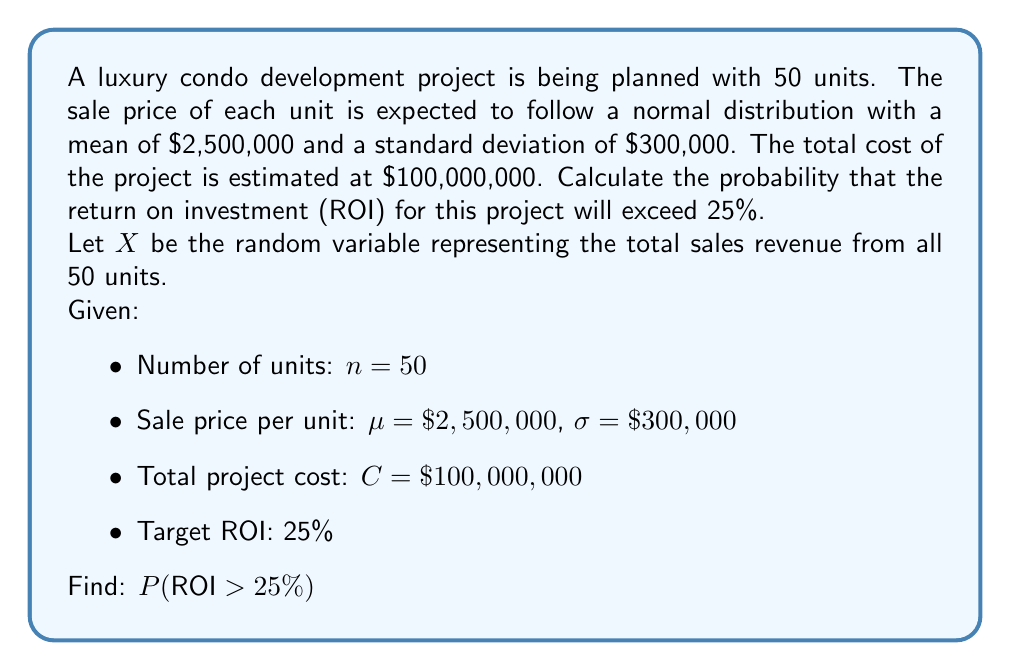What is the answer to this math problem? To solve this problem, we'll follow these steps:

1) First, let's define ROI:
   $ROI = \frac{\text{Revenue} - \text{Cost}}{\text{Cost}}$

2) We want to find $P(ROI > 25\%)$, which is equivalent to:
   $P(\frac{X - C}{C} > 0.25)$, where $X$ is the total sales revenue

3) Simplify this inequality:
   $P(X - C > 0.25C)$
   $P(X > 1.25C)$
   $P(X > 1.25 \times \$100,000,000)$
   $P(X > \$125,000,000)$

4) Now, we need to find the distribution of $X$. Since $X$ is the sum of 50 normally distributed random variables:
   $X \sim N(n\mu, \sqrt{n}\sigma)$
   $X \sim N(50 \times \$2,500,000, \sqrt{50} \times \$300,000)$
   $X \sim N(\$125,000,000, \$2,121,320)$

5) We can now standardize this to a Z-score:
   $Z = \frac{X - \mu}{\sigma} = \frac{X - \$125,000,000}{\$2,121,320}$

6) Our problem has become:
   $P(X > \$125,000,000) = P(Z > 0)$

7) From the standard normal distribution table, we know:
   $P(Z > 0) = 0.5$

Therefore, the probability that the ROI will exceed 25% is 0.5 or 50%.
Answer: 0.5 